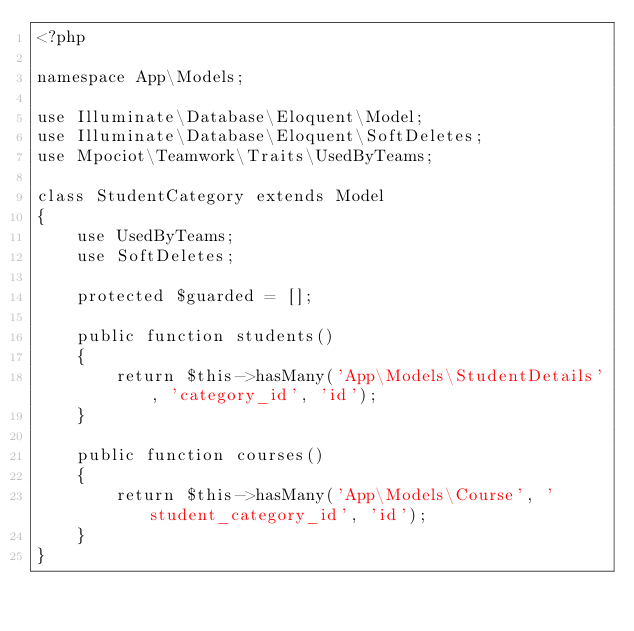Convert code to text. <code><loc_0><loc_0><loc_500><loc_500><_PHP_><?php

namespace App\Models;

use Illuminate\Database\Eloquent\Model;
use Illuminate\Database\Eloquent\SoftDeletes;
use Mpociot\Teamwork\Traits\UsedByTeams;

class StudentCategory extends Model
{
    use UsedByTeams;
    use SoftDeletes;

    protected $guarded = [];

    public function students()
    {
    	return $this->hasMany('App\Models\StudentDetails', 'category_id', 'id');
    }

    public function courses()
    {
        return $this->hasMany('App\Models\Course', 'student_category_id', 'id');
    }
}
</code> 